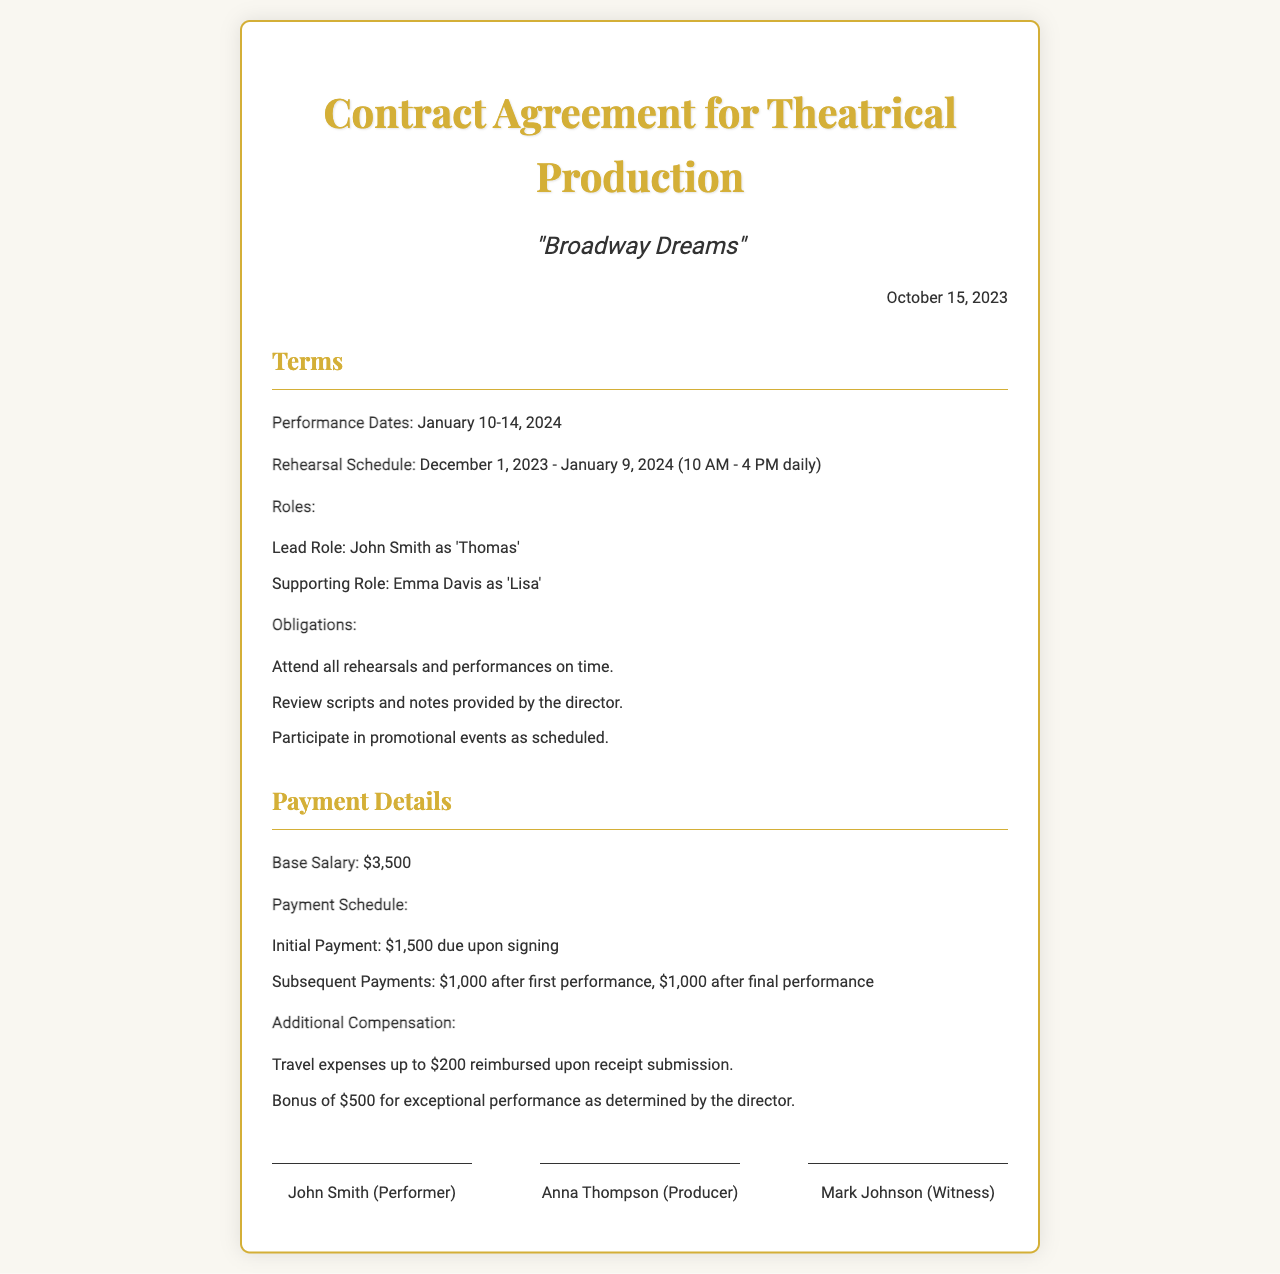What are the performance dates? The performance dates are explicitly stated in the document.
Answer: January 10-14, 2024 What is the base salary for the performer? The base salary is mentioned clearly in the payment details section.
Answer: $3,500 Who is responsible for signing the contract as the performer? The document identifies the signatures and roles of the individuals involved.
Answer: John Smith What is the initial payment due upon signing? The payment schedule outlines the amounts and timing for payments.
Answer: $1,500 When does the rehearsal schedule start? The document specifies the start date of the rehearsal schedule.
Answer: December 1, 2023 How much is the bonus for exceptional performance? The additional compensation section mentions the bonus amount explicitly.
Answer: $500 What are the daily rehearsal hours? The rehearsal schedule provides specific daily hours for rehearsals.
Answer: 10 AM - 4 PM What is the obligation regarding promotional events? The obligations section details the expectations for promotional events.
Answer: Participate What travel expenses are reimbursed? The document outlines the specifics of what travel expenses can be reimbursed.
Answer: Up to $200 